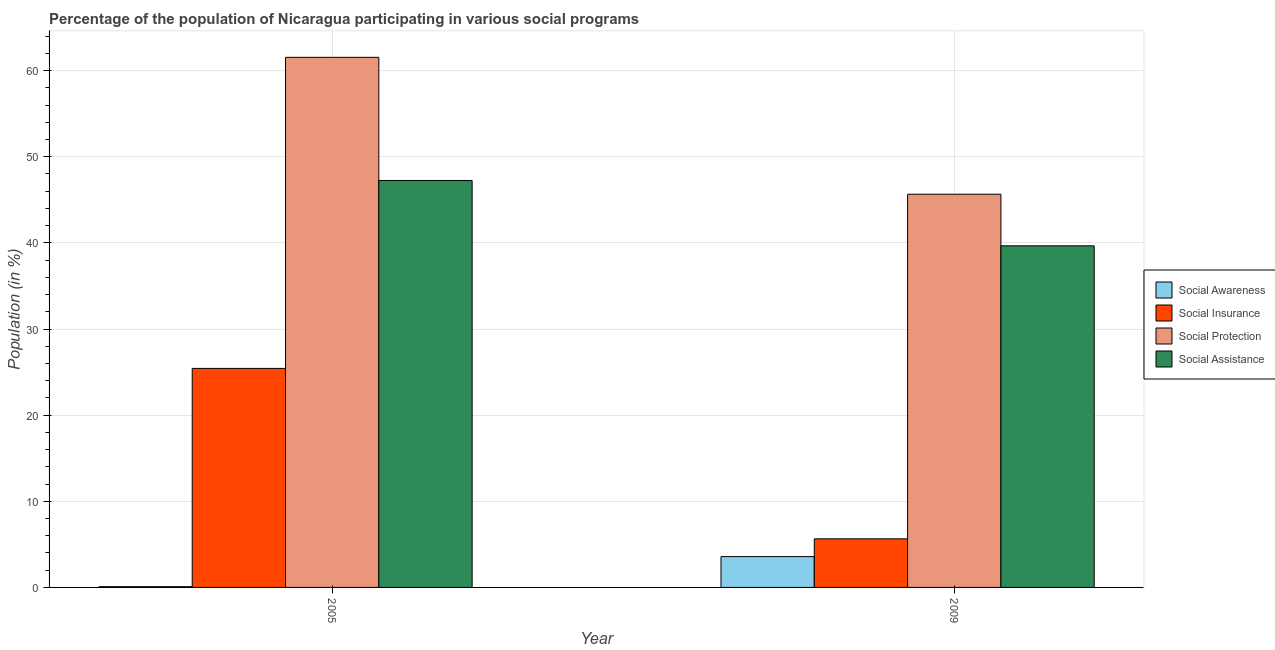How many different coloured bars are there?
Keep it short and to the point. 4. How many groups of bars are there?
Keep it short and to the point. 2. Are the number of bars per tick equal to the number of legend labels?
Offer a very short reply. Yes. Are the number of bars on each tick of the X-axis equal?
Offer a very short reply. Yes. How many bars are there on the 1st tick from the left?
Provide a short and direct response. 4. What is the participation of population in social protection programs in 2009?
Provide a succinct answer. 45.65. Across all years, what is the maximum participation of population in social insurance programs?
Provide a succinct answer. 25.43. Across all years, what is the minimum participation of population in social insurance programs?
Your response must be concise. 5.64. In which year was the participation of population in social insurance programs minimum?
Give a very brief answer. 2009. What is the total participation of population in social insurance programs in the graph?
Your answer should be compact. 31.07. What is the difference between the participation of population in social protection programs in 2005 and that in 2009?
Ensure brevity in your answer.  15.89. What is the difference between the participation of population in social insurance programs in 2005 and the participation of population in social awareness programs in 2009?
Provide a succinct answer. 19.79. What is the average participation of population in social insurance programs per year?
Offer a terse response. 15.53. In the year 2005, what is the difference between the participation of population in social protection programs and participation of population in social insurance programs?
Give a very brief answer. 0. What is the ratio of the participation of population in social insurance programs in 2005 to that in 2009?
Provide a succinct answer. 4.51. Is it the case that in every year, the sum of the participation of population in social assistance programs and participation of population in social awareness programs is greater than the sum of participation of population in social protection programs and participation of population in social insurance programs?
Make the answer very short. Yes. What does the 1st bar from the left in 2009 represents?
Provide a short and direct response. Social Awareness. What does the 1st bar from the right in 2005 represents?
Give a very brief answer. Social Assistance. Is it the case that in every year, the sum of the participation of population in social awareness programs and participation of population in social insurance programs is greater than the participation of population in social protection programs?
Your answer should be compact. No. How many bars are there?
Make the answer very short. 8. Are all the bars in the graph horizontal?
Offer a very short reply. No. How many years are there in the graph?
Ensure brevity in your answer.  2. What is the difference between two consecutive major ticks on the Y-axis?
Offer a terse response. 10. Are the values on the major ticks of Y-axis written in scientific E-notation?
Give a very brief answer. No. Does the graph contain grids?
Offer a very short reply. Yes. What is the title of the graph?
Your answer should be very brief. Percentage of the population of Nicaragua participating in various social programs . Does "Fourth 20% of population" appear as one of the legend labels in the graph?
Your answer should be compact. No. What is the label or title of the X-axis?
Offer a very short reply. Year. What is the Population (in %) in Social Awareness in 2005?
Provide a succinct answer. 0.09. What is the Population (in %) in Social Insurance in 2005?
Offer a terse response. 25.43. What is the Population (in %) in Social Protection in 2005?
Your answer should be compact. 61.55. What is the Population (in %) of Social Assistance in 2005?
Keep it short and to the point. 47.25. What is the Population (in %) of Social Awareness in 2009?
Make the answer very short. 3.58. What is the Population (in %) in Social Insurance in 2009?
Give a very brief answer. 5.64. What is the Population (in %) of Social Protection in 2009?
Provide a short and direct response. 45.65. What is the Population (in %) of Social Assistance in 2009?
Your response must be concise. 39.66. Across all years, what is the maximum Population (in %) of Social Awareness?
Give a very brief answer. 3.58. Across all years, what is the maximum Population (in %) of Social Insurance?
Offer a terse response. 25.43. Across all years, what is the maximum Population (in %) of Social Protection?
Your answer should be very brief. 61.55. Across all years, what is the maximum Population (in %) in Social Assistance?
Offer a very short reply. 47.25. Across all years, what is the minimum Population (in %) in Social Awareness?
Provide a short and direct response. 0.09. Across all years, what is the minimum Population (in %) of Social Insurance?
Offer a terse response. 5.64. Across all years, what is the minimum Population (in %) in Social Protection?
Offer a very short reply. 45.65. Across all years, what is the minimum Population (in %) of Social Assistance?
Your response must be concise. 39.66. What is the total Population (in %) in Social Awareness in the graph?
Your answer should be very brief. 3.67. What is the total Population (in %) in Social Insurance in the graph?
Make the answer very short. 31.07. What is the total Population (in %) in Social Protection in the graph?
Keep it short and to the point. 107.2. What is the total Population (in %) of Social Assistance in the graph?
Offer a very short reply. 86.91. What is the difference between the Population (in %) of Social Awareness in 2005 and that in 2009?
Ensure brevity in your answer.  -3.49. What is the difference between the Population (in %) of Social Insurance in 2005 and that in 2009?
Give a very brief answer. 19.79. What is the difference between the Population (in %) in Social Protection in 2005 and that in 2009?
Offer a terse response. 15.89. What is the difference between the Population (in %) of Social Assistance in 2005 and that in 2009?
Your answer should be very brief. 7.59. What is the difference between the Population (in %) in Social Awareness in 2005 and the Population (in %) in Social Insurance in 2009?
Ensure brevity in your answer.  -5.55. What is the difference between the Population (in %) of Social Awareness in 2005 and the Population (in %) of Social Protection in 2009?
Provide a short and direct response. -45.56. What is the difference between the Population (in %) in Social Awareness in 2005 and the Population (in %) in Social Assistance in 2009?
Offer a terse response. -39.57. What is the difference between the Population (in %) in Social Insurance in 2005 and the Population (in %) in Social Protection in 2009?
Offer a very short reply. -20.22. What is the difference between the Population (in %) in Social Insurance in 2005 and the Population (in %) in Social Assistance in 2009?
Make the answer very short. -14.23. What is the difference between the Population (in %) of Social Protection in 2005 and the Population (in %) of Social Assistance in 2009?
Your response must be concise. 21.89. What is the average Population (in %) in Social Awareness per year?
Ensure brevity in your answer.  1.83. What is the average Population (in %) in Social Insurance per year?
Your answer should be very brief. 15.53. What is the average Population (in %) in Social Protection per year?
Your answer should be compact. 53.6. What is the average Population (in %) in Social Assistance per year?
Your response must be concise. 43.45. In the year 2005, what is the difference between the Population (in %) in Social Awareness and Population (in %) in Social Insurance?
Provide a succinct answer. -25.34. In the year 2005, what is the difference between the Population (in %) in Social Awareness and Population (in %) in Social Protection?
Ensure brevity in your answer.  -61.46. In the year 2005, what is the difference between the Population (in %) in Social Awareness and Population (in %) in Social Assistance?
Make the answer very short. -47.16. In the year 2005, what is the difference between the Population (in %) in Social Insurance and Population (in %) in Social Protection?
Your response must be concise. -36.12. In the year 2005, what is the difference between the Population (in %) of Social Insurance and Population (in %) of Social Assistance?
Keep it short and to the point. -21.82. In the year 2005, what is the difference between the Population (in %) of Social Protection and Population (in %) of Social Assistance?
Offer a very short reply. 14.3. In the year 2009, what is the difference between the Population (in %) of Social Awareness and Population (in %) of Social Insurance?
Offer a terse response. -2.06. In the year 2009, what is the difference between the Population (in %) of Social Awareness and Population (in %) of Social Protection?
Ensure brevity in your answer.  -42.07. In the year 2009, what is the difference between the Population (in %) of Social Awareness and Population (in %) of Social Assistance?
Provide a short and direct response. -36.08. In the year 2009, what is the difference between the Population (in %) of Social Insurance and Population (in %) of Social Protection?
Offer a very short reply. -40.01. In the year 2009, what is the difference between the Population (in %) of Social Insurance and Population (in %) of Social Assistance?
Give a very brief answer. -34.02. In the year 2009, what is the difference between the Population (in %) of Social Protection and Population (in %) of Social Assistance?
Ensure brevity in your answer.  5.99. What is the ratio of the Population (in %) of Social Awareness in 2005 to that in 2009?
Your response must be concise. 0.02. What is the ratio of the Population (in %) in Social Insurance in 2005 to that in 2009?
Provide a succinct answer. 4.51. What is the ratio of the Population (in %) in Social Protection in 2005 to that in 2009?
Keep it short and to the point. 1.35. What is the ratio of the Population (in %) in Social Assistance in 2005 to that in 2009?
Ensure brevity in your answer.  1.19. What is the difference between the highest and the second highest Population (in %) of Social Awareness?
Offer a very short reply. 3.49. What is the difference between the highest and the second highest Population (in %) in Social Insurance?
Your response must be concise. 19.79. What is the difference between the highest and the second highest Population (in %) of Social Protection?
Your answer should be very brief. 15.89. What is the difference between the highest and the second highest Population (in %) in Social Assistance?
Make the answer very short. 7.59. What is the difference between the highest and the lowest Population (in %) of Social Awareness?
Provide a succinct answer. 3.49. What is the difference between the highest and the lowest Population (in %) in Social Insurance?
Provide a short and direct response. 19.79. What is the difference between the highest and the lowest Population (in %) of Social Protection?
Offer a terse response. 15.89. What is the difference between the highest and the lowest Population (in %) in Social Assistance?
Your response must be concise. 7.59. 